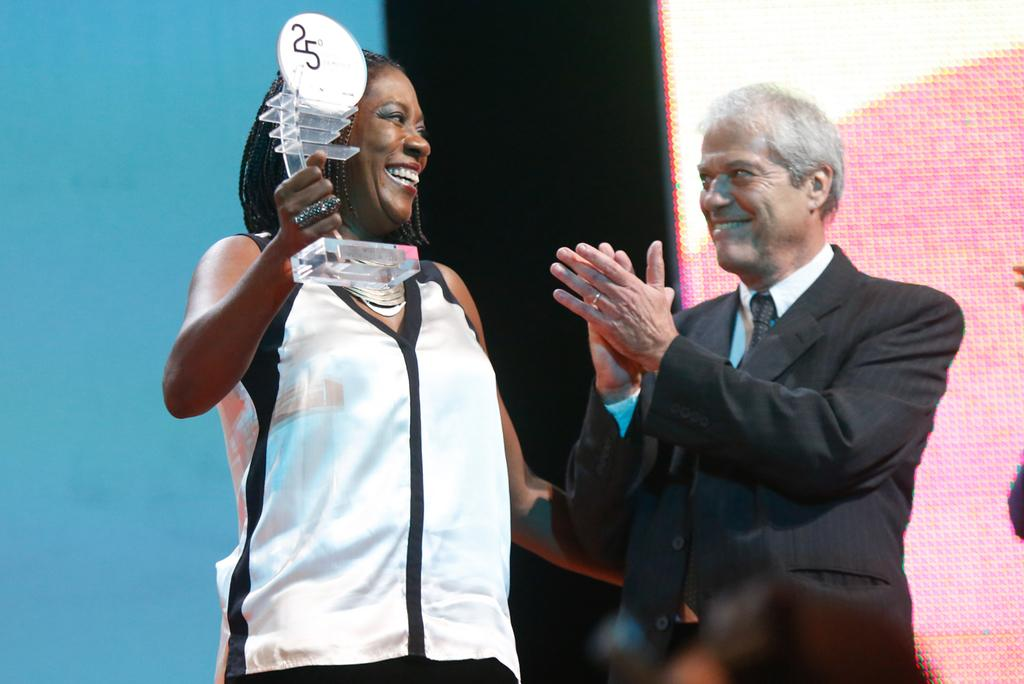What is the man in the image wearing? The man is wearing a suit. What is the man doing in the image? The man is standing and smiling. Who else is present in the image? There is a woman in the image. What is the woman holding in the image? The woman is holding an award. What can be seen in the background of the image? There is a wall in the background of the image. What type of button can be seen on the man's suit in the image? There is no button visible on the man's suit in the image. How many apples are present on the wall in the image? There are no apples present on the wall in the image. 